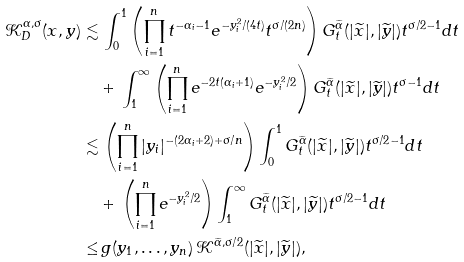Convert formula to latex. <formula><loc_0><loc_0><loc_500><loc_500>\mathcal { K } _ { D } ^ { \alpha , \sigma } ( x , y ) \lesssim & \, \int _ { 0 } ^ { 1 } \left ( \prod _ { i = 1 } ^ { n } t ^ { - \alpha _ { i } - 1 } e ^ { - y _ { i } ^ { 2 } \slash ( 4 t ) } t ^ { \sigma \slash ( 2 n ) } \right ) G _ { t } ^ { \widetilde { \alpha } } ( | \widetilde { x } | , | \widetilde { y } | ) t ^ { \sigma \slash 2 - 1 } d t \\ & + \, \int _ { 1 } ^ { \infty } \left ( \prod _ { i = 1 } ^ { n } e ^ { - 2 t ( \alpha _ { i } + 1 ) } e ^ { - y _ { i } ^ { 2 } \slash 2 } \right ) G _ { t } ^ { \widetilde { \alpha } } ( | \widetilde { x } | , | \widetilde { y } | ) t ^ { \sigma - 1 } d t \\ \lesssim & \, \left ( \prod _ { i = 1 } ^ { n } | y _ { i } | ^ { - ( 2 \alpha _ { i } + 2 ) + \sigma \slash n } \right ) \int _ { 0 } ^ { 1 } G _ { t } ^ { \widetilde { \alpha } } ( | \widetilde { x } | , | \widetilde { y } | ) t ^ { \sigma \slash 2 - 1 } d t \\ & + \, \left ( \prod _ { i = 1 } ^ { n } e ^ { - y _ { i } ^ { 2 } \slash 2 } \right ) \int _ { 1 } ^ { \infty } G _ { t } ^ { \widetilde { \alpha } } ( | \widetilde { x } | , | \widetilde { y } | ) t ^ { \sigma \slash 2 - 1 } d t \\ \leq & \, g ( y _ { 1 } , \dots , y _ { n } ) \, \mathcal { K } ^ { \widetilde { \alpha } , \sigma \slash 2 } ( | \widetilde { x } | , | \widetilde { y } | ) ,</formula> 